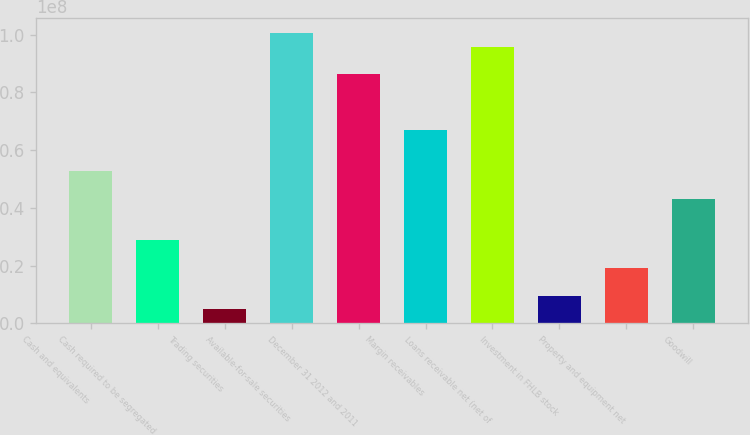<chart> <loc_0><loc_0><loc_500><loc_500><bar_chart><fcel>Cash and equivalents<fcel>Cash required to be segregated<fcel>Trading securities<fcel>Available-for-sale securities<fcel>December 31 2012 and 2011<fcel>Margin receivables<fcel>Loans receivable net (net of<fcel>Investment in FHLB stock<fcel>Property and equipment net<fcel>Goodwill<nl><fcel>5.27342e+07<fcel>2.87654e+07<fcel>4.79661e+06<fcel>1.00672e+08<fcel>8.62905e+07<fcel>6.71155e+07<fcel>9.5878e+07<fcel>9.59037e+06<fcel>1.91779e+07<fcel>4.31467e+07<nl></chart> 